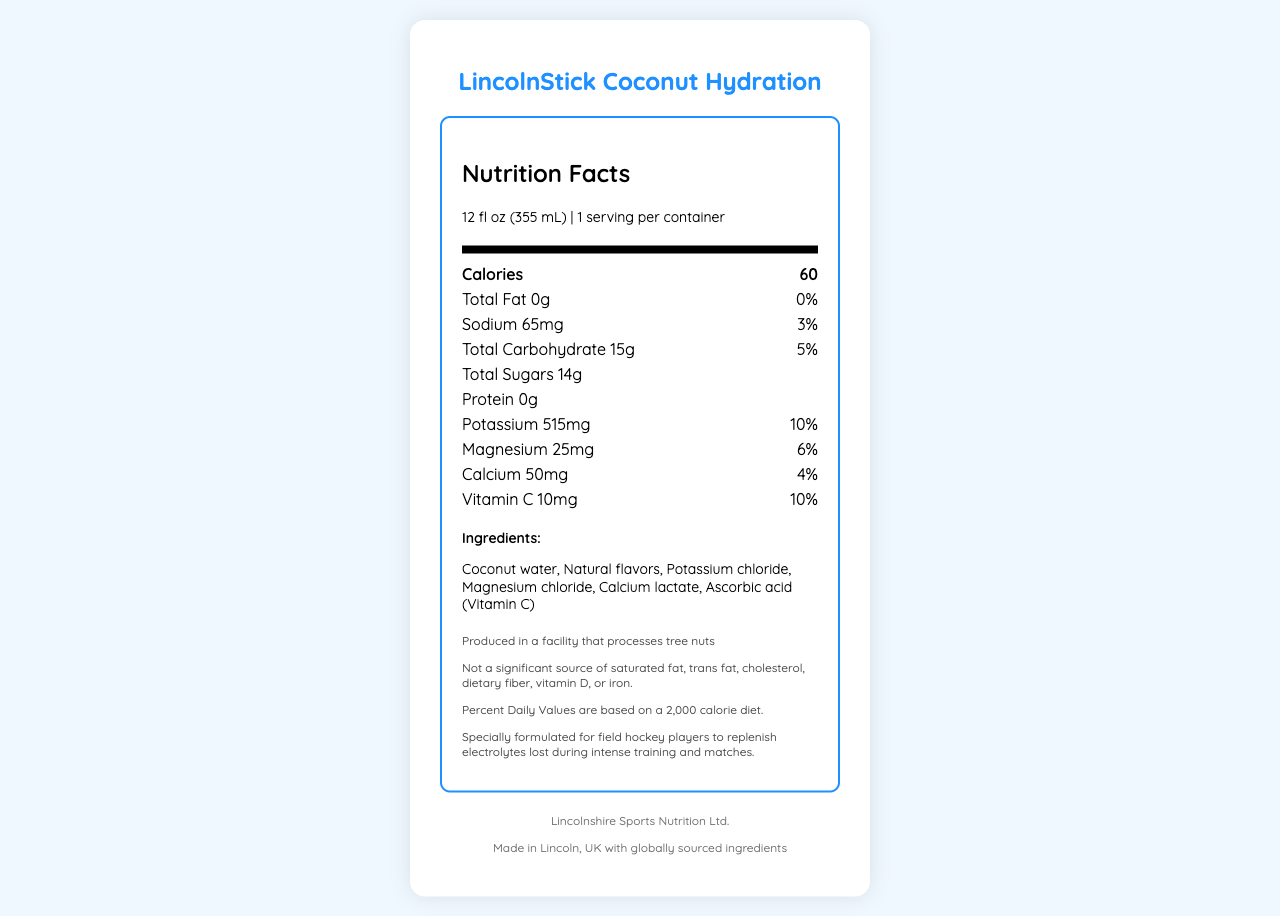what is the serving size of LincolnStick Coconut Hydration? The serving size is listed as "12 fl oz (355 mL)" under the "Nutrition Facts" header.
Answer: 12 fl oz (355 mL) how many calories are in one serving of this beverage? The calories per serving are listed next to the "Calories" label.
Answer: 60 how much sodium does one serving provide? The sodium content is listed as "65mg" with a daily value of "3%".
Answer: 65mg what percentage of the daily value of potassium does this drink provide? The potassium percentage of daily value is listed as "10%" with an amount of "515mg".
Answer: 10% how much vitamin C is present in one serving of this drink? The vitamin C content is listed as "10mg" with a daily value of "10%".
Answer: 10mg how many grams of total sugars are in this beverage? A. 10g B. 12g C. 14g D. 16g The total sugars are listed as "14g".
Answer: C which ingredient is NOT present in LincolnStick Coconut Hydration? A. Coconut water B. Ascorbic acid C. High fructose corn syrup D. Magnesium chloride The ingredients list includes "Coconut water", "Ascorbic acid (Vitamin C)", and "Magnesium chloride", but not "High fructose corn syrup".
Answer: C is this beverage a significant source of dietary fiber? The additional information states, "Not a significant source of saturated fat, trans fat, cholesterol, dietary fiber, vitamin D, or iron."
Answer: No who is the manufacturer of this coconut water beverage? The manufacturer information is listed at the bottom of the document.
Answer: Lincolnshire Sports Nutrition Ltd. where is this product made? The origin section states it is "Made in Lincoln, UK with globally sourced ingredients."
Answer: Lincoln, UK was this beverage specially formulated for field hockey players? The additional information mentions that it is "Specially formulated for field hockey players to replenish electrolytes lost during intense training and matches."
Answer: Yes summarize the main idea of the document. The document details the product's nutrition information, ingredients, and target audience, highlighting its benefits for hydration and electrolyte replenishment, along with manufacturer and origin details.
Answer: This document provides the nutrition facts and ingredient details for LincolnStick Coconut Hydration, a hydrating coconut water beverage with added minerals, formulated for field hockey players. It lists serving size, calories, and nutritional content, emphasizing its electrolyte-replenishing properties. It also mentions the manufacturer and origin. what is the price of one container of LincolnStick Coconut Hydration? The document does not provide any information about the price of the product.
Answer: Not enough information 